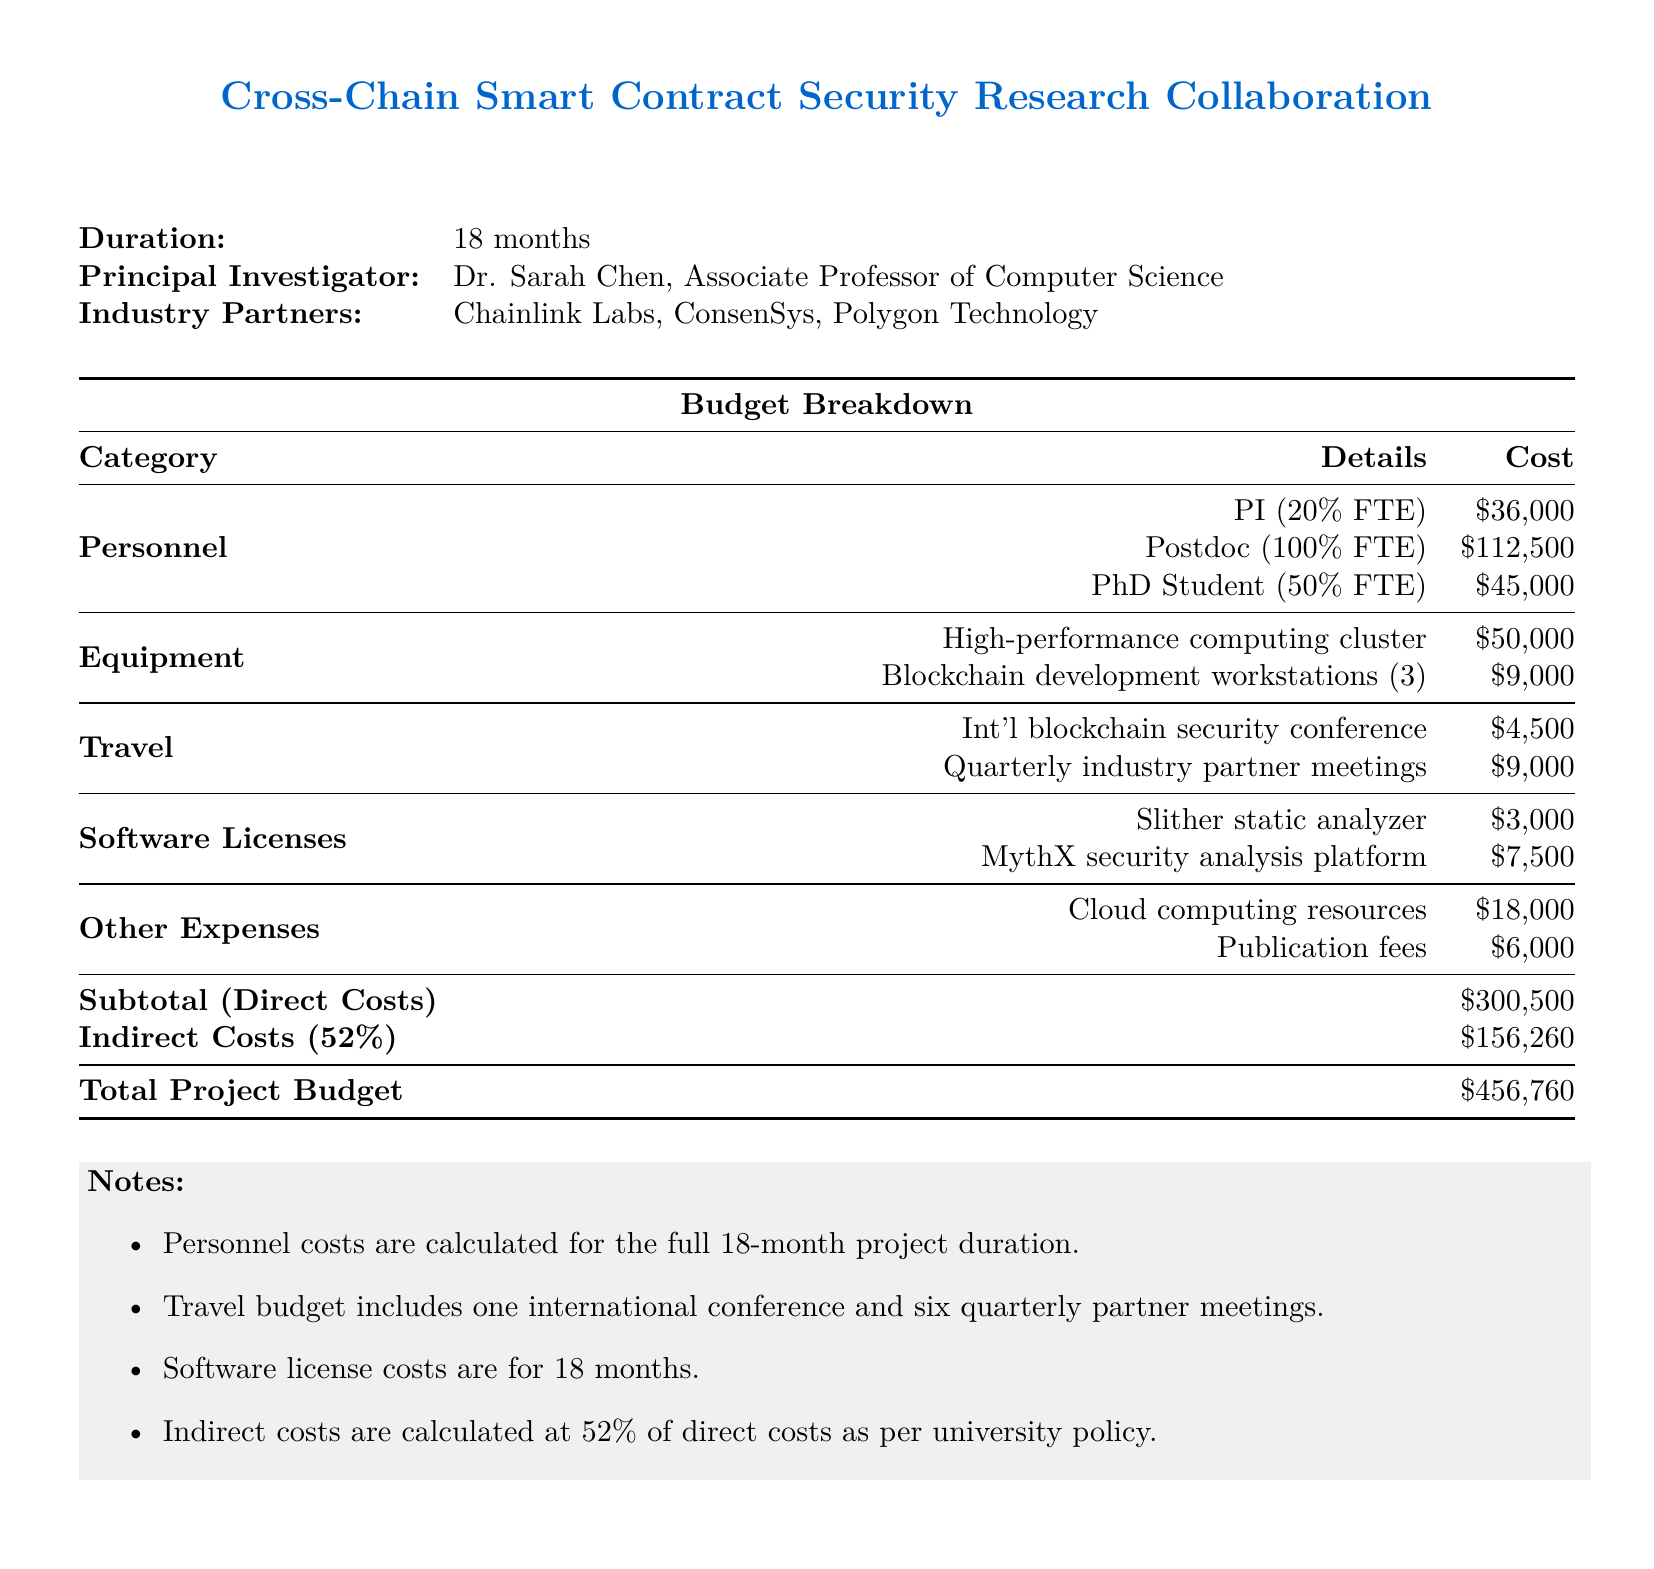What is the duration of the project? The duration of the project is stated directly in the document as 18 months.
Answer: 18 months Who is the Principal Investigator? The document lists Dr. Sarah Chen as the Principal Investigator.
Answer: Dr. Sarah Chen What is the total project budget? The total project budget is explicitly mentioned at the bottom of the budget breakdown as $456,760.
Answer: $456,760 How much is allocated for personnel costs? The subtotal for direct costs includes all personnel costs, which sums to $193,500.
Answer: $193,500 What percentage of FTE is the Postdoc? The document specifies the Postdoc as being 100% FTE, meaning Full-Time Equivalent.
Answer: 100% FTE What is the cost for travel to the international conference? The document lists the travel cost to the international blockchain security conference as $4,500.
Answer: $4,500 How much are the indirect costs calculated as? The indirect costs are calculated based on the policy at 52% of direct costs, which total $156,260.
Answer: $156,260 What are the publication fees listed in the budget? The budget outlines publication fees as being a specific amount, which is $6,000.
Answer: $6,000 How many blockchain development workstations are included in the equipment costs? The document specifies that there are three blockchain development workstations included in the equipment costs.
Answer: 3 